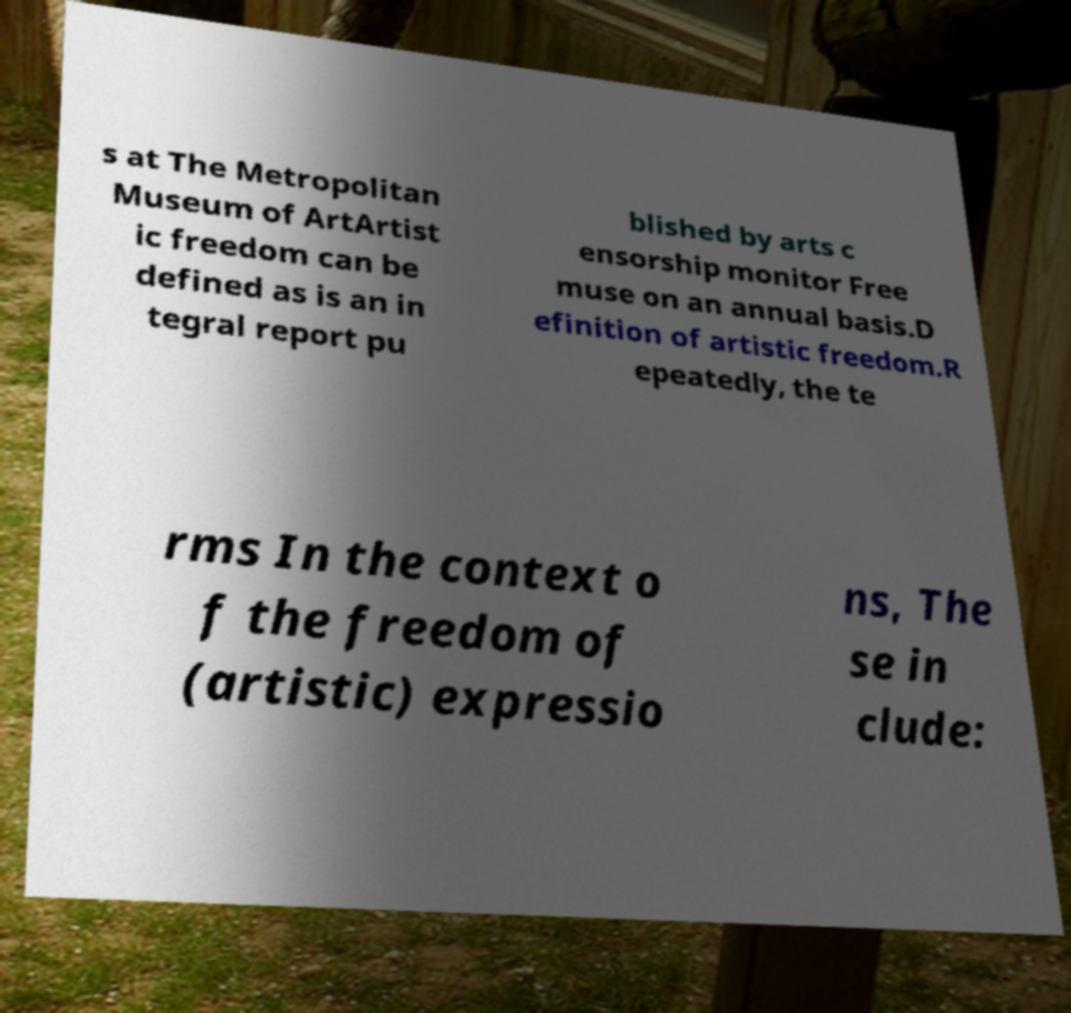Can you read and provide the text displayed in the image?This photo seems to have some interesting text. Can you extract and type it out for me? s at The Metropolitan Museum of ArtArtist ic freedom can be defined as is an in tegral report pu blished by arts c ensorship monitor Free muse on an annual basis.D efinition of artistic freedom.R epeatedly, the te rms In the context o f the freedom of (artistic) expressio ns, The se in clude: 